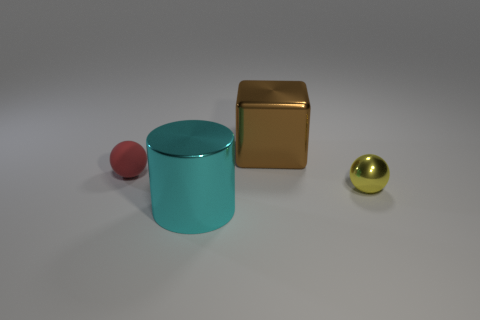What is the shape of the large cyan thing? The large cyan object in the image is a perfect cylinder, featuring two circular faces that are parallel to one another and a curved surface that connects them. 